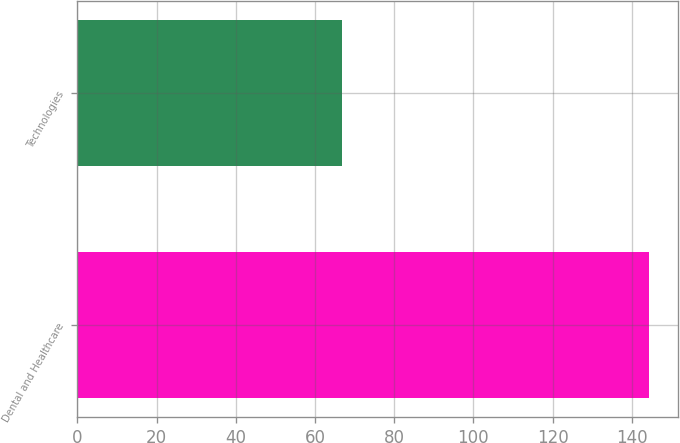<chart> <loc_0><loc_0><loc_500><loc_500><bar_chart><fcel>Dental and Healthcare<fcel>Technologies<nl><fcel>144.4<fcel>66.8<nl></chart> 